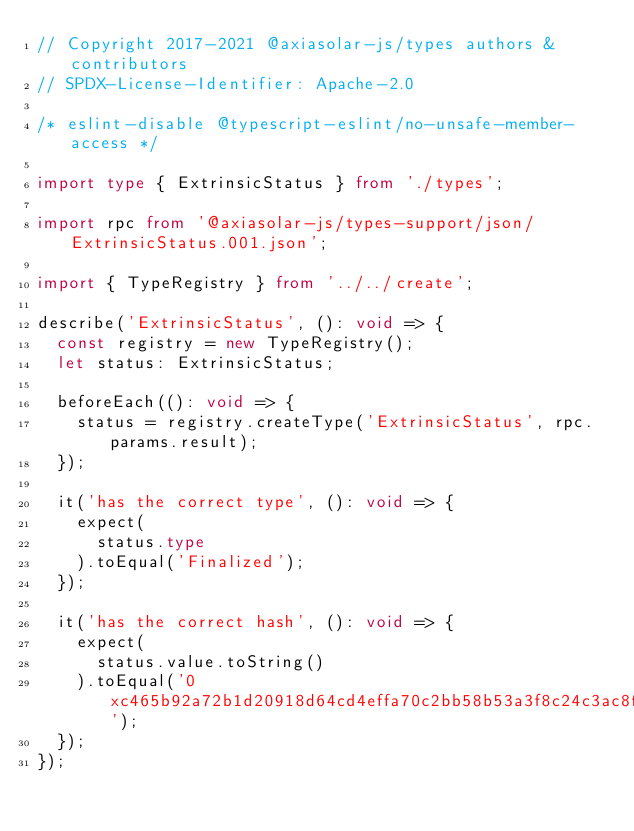Convert code to text. <code><loc_0><loc_0><loc_500><loc_500><_TypeScript_>// Copyright 2017-2021 @axiasolar-js/types authors & contributors
// SPDX-License-Identifier: Apache-2.0

/* eslint-disable @typescript-eslint/no-unsafe-member-access */

import type { ExtrinsicStatus } from './types';

import rpc from '@axiasolar-js/types-support/json/ExtrinsicStatus.001.json';

import { TypeRegistry } from '../../create';

describe('ExtrinsicStatus', (): void => {
  const registry = new TypeRegistry();
  let status: ExtrinsicStatus;

  beforeEach((): void => {
    status = registry.createType('ExtrinsicStatus', rpc.params.result);
  });

  it('has the correct type', (): void => {
    expect(
      status.type
    ).toEqual('Finalized');
  });

  it('has the correct hash', (): void => {
    expect(
      status.value.toString()
    ).toEqual('0xc465b92a72b1d20918d64cd4effa70c2bb58b53a3f8c24c3ac8fd8f465f059b4');
  });
});
</code> 